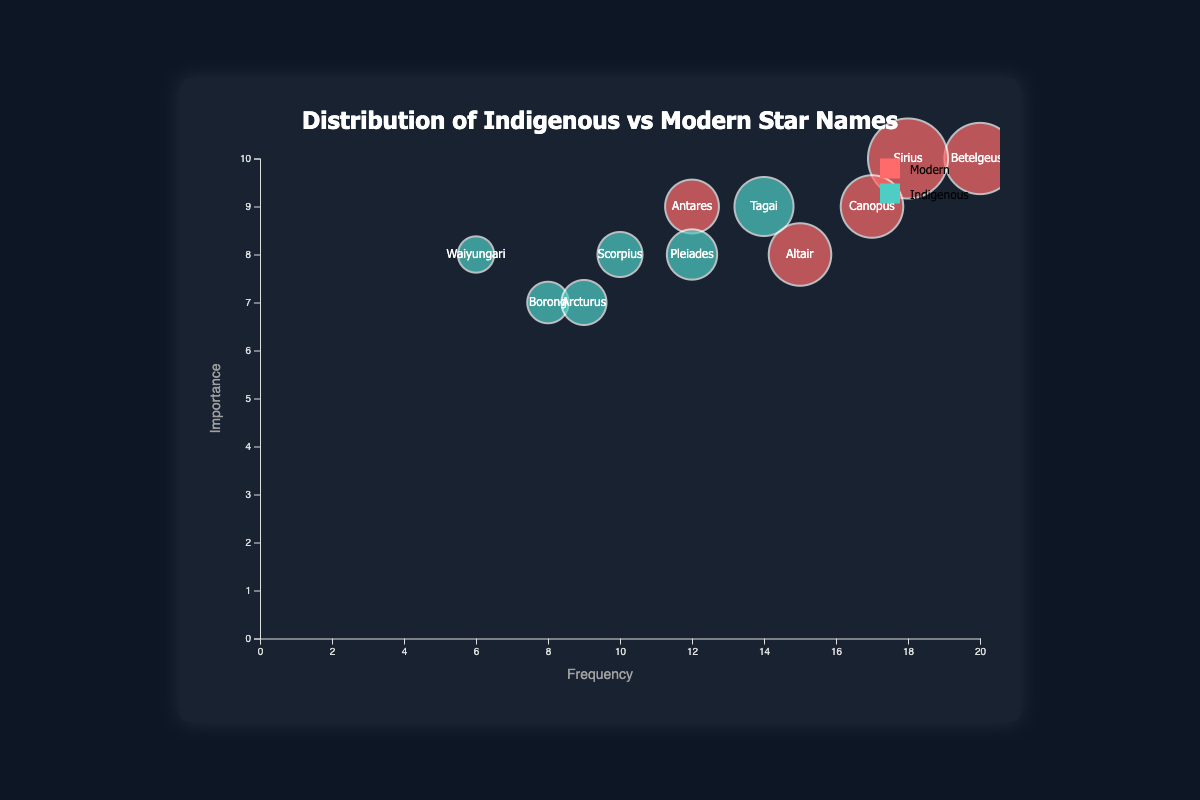Which star name has the highest frequency? The bubble furthest to the right represents the star with the highest frequency. By observing the x-axis (Frequency), we notice that "Betelgeuse" is the furthest right.
Answer: Betelgeuse What is the importance value of "Tagai"? Locate the bubble labeled "Tagai" and check its position on the y-axis (Importance).
Answer: 9 How many star names are from Indigenous traditions? Look for the bubbles colored in the shade representing Indigenous star names, count them based on color differences. There are 6 different bubbles for Indigenous names.
Answer: 6 How does the size of "Sirius" compare to "Waiyungari"? Compare the bubble sizes labeled "Sirius" and "Waiyungari". The size of Sirius is much larger compared to Waiyungari due to different radius measurements.
Answer: Sirius is larger Which star name in the Modern tradition has the highest importance value? Identify and compare the y-axis positions of bubbles corresponding to the Modern tradition, notice the one furthest upward. "Betelgeuse" and "Sirius" both have the highest importance values.
Answer: Betelgeuse and Sirius What is the total frequency of Indigenous star names? Sum the frequencies by adding them directly from the data of Indigenous stars: (10 + 8 + 6 + 14 + 9 + 12) = 59
Answer: 59 For Indigenous traditions, which star name has the lowest frequency and how does its importance compare to the highest frequency star name in the same group? The Star with the lowest frequency is "Waiyungari" (frequency 6) and the one with the highest frequency in the same group is "Tagai" (frequency 14). Compare their importance values (both 8 and 9 respectively).
Answer: Waiyungari, 8 < 9 Which Modern star name has the smallest bubble size and how does its frequency compare to Canopus? Looking at the sizes of the bubbles for Modern stars, "Antares" has a bubble size of 250 which is the smallest compared to others in the Modern group. Compare the frequencies: 12 (Antares) compared to 17 (Canopus).
Answer: Antares, 12 < 17 What is the frequency range for the Indigenous star names? Determine the minimum and maximum frequency values among Indigenous star names: (6 to 14).
Answer: 6 to 14 